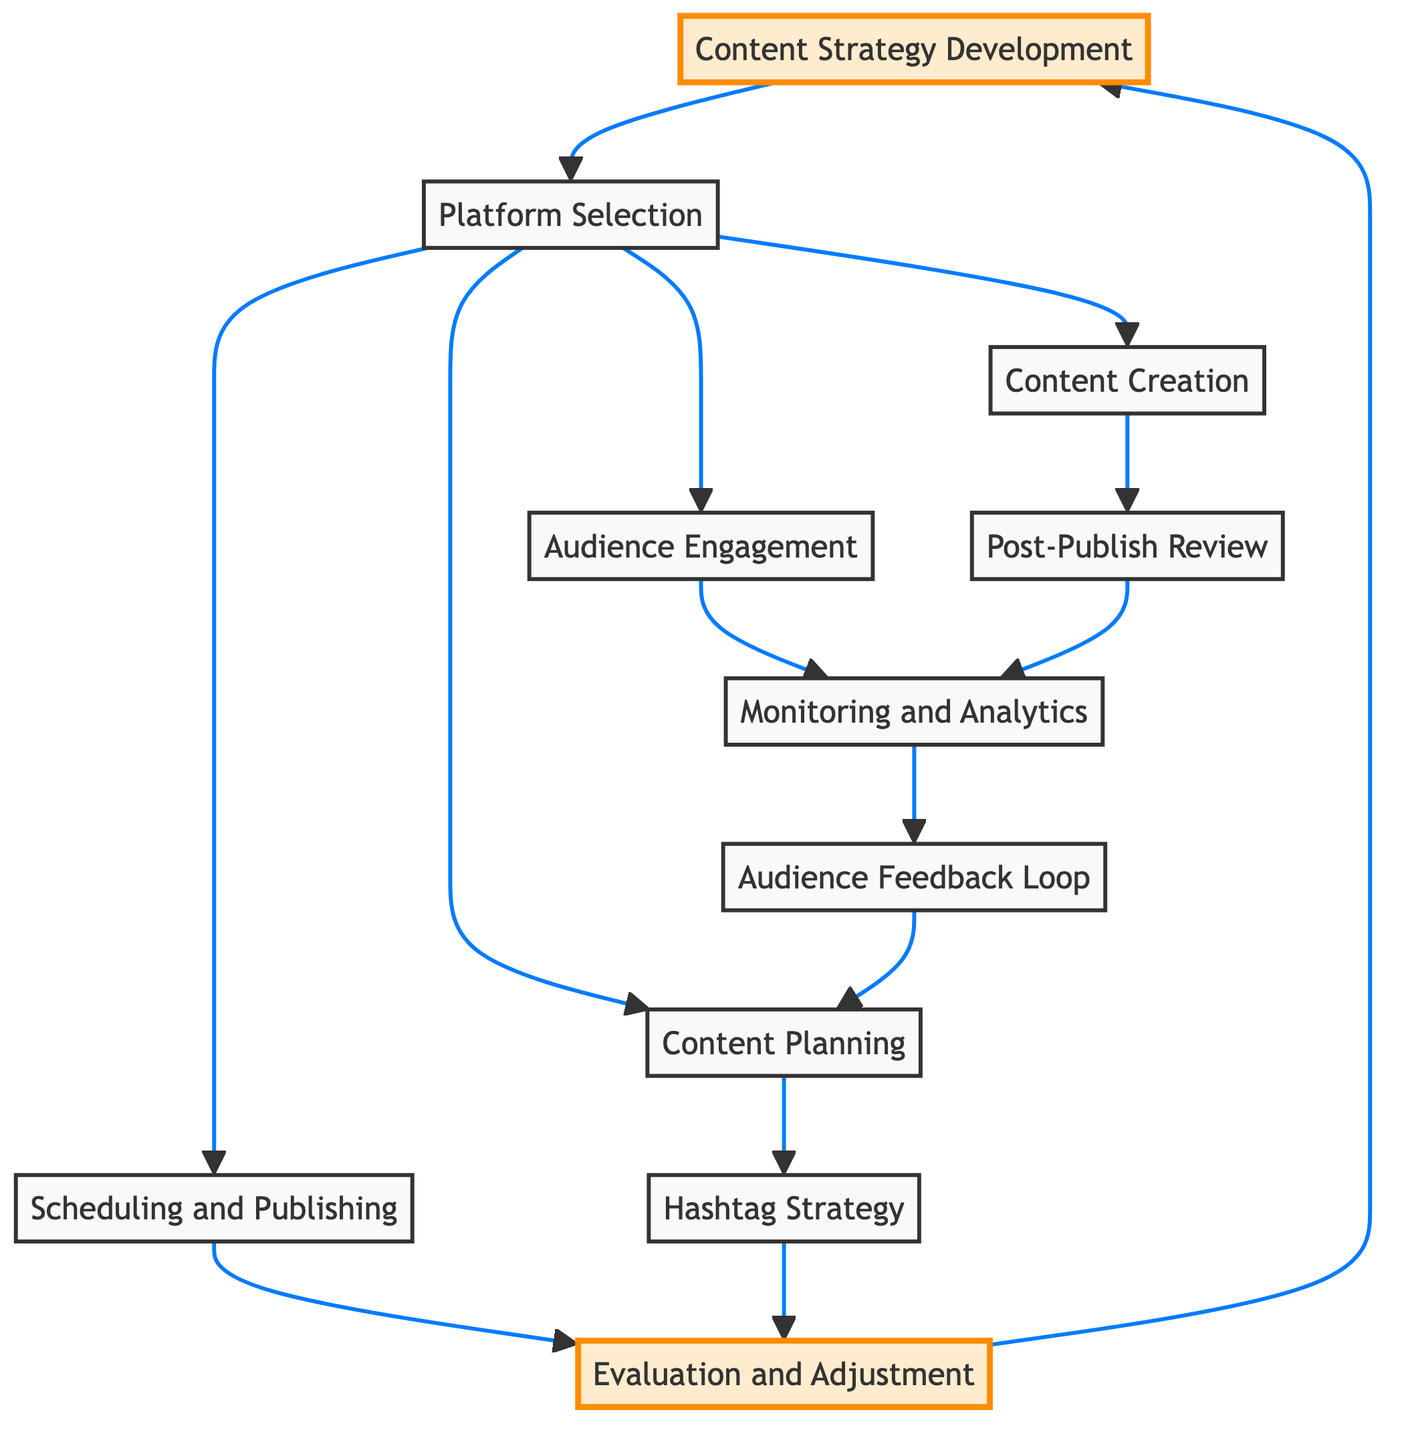What is the first step in the content strategy process? The diagram shows that the first step is "Content Strategy Development". This is indicated by the direction of the arrow starting from node 1, which leads to the next step.
Answer: Content Strategy Development How many platforms are selectable after the platform selection step? From the diagram, the "Platform Selection" node (2) has four outgoing connections (3, 4, 5, 6), indicating four different pathways that can be followed after selecting a platform.
Answer: Four What is the purpose of the hashtag strategy? In the diagram, the "Hashtag Strategy" node (7) is connected to "Content Planning" (3), indicating it serves to enhance the planning by increasing content reach through hashtag usage.
Answer: Increase reach What action follows content creation in the diagram? The "Content Creation" node (5) points to the "Post-Publish Review" node (9), showing that after creating content, the next action is to review how well the content performed after it was published.
Answer: Post-Publish Review What connects to the audience feedback loop? The "Audience Feedback Loop" node (11) is connected to the "Monitoring and Analytics" node (8) in the diagram, indicating that it uses the information gathered from monitoring performance to inform the feedback loop.
Answer: Monitoring and Analytics Which nodes are highlighted in the diagram? The highlighted nodes in the diagram—indicating their significance—are nodes 1 (Content Strategy Development) and 10 (Evaluation and Adjustment), as they have been emphasized visually.
Answer: Content Strategy Development, Evaluation and Adjustment What type of content planning strategies can be included after selecting a platform? After the "Platform Selection" step (2), the "Content Planning" step (3) can cover a variety of content types listed as articles, videos, and infographics based on what is seen in the diagram.
Answer: Articles, videos, infographics What is the last step before returning to content strategy development? The last node before returning to the "Content Strategy Development" (1) is the "Evaluation and Adjustment" (10) which suggests assessing previous steps and adjusting accordingly before starting again.
Answer: Evaluation and Adjustment 